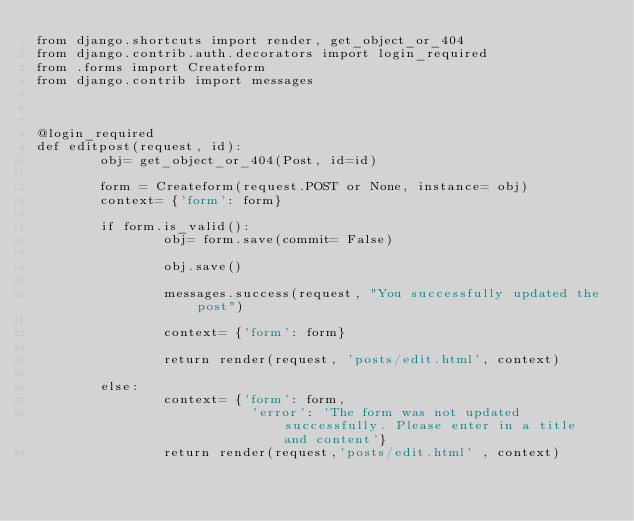Convert code to text. <code><loc_0><loc_0><loc_500><loc_500><_Python_>from django.shortcuts import render, get_object_or_404
from django.contrib.auth.decorators import login_required
from .forms import Createform
from django.contrib import messages



@login_required
def editpost(request, id):
        obj= get_object_or_404(Post, id=id)
        
        form = Createform(request.POST or None, instance= obj)
        context= {'form': form}

        if form.is_valid():
                obj= form.save(commit= False)

                obj.save()

                messages.success(request, "You successfully updated the post")

                context= {'form': form}

                return render(request, 'posts/edit.html', context)

        else:
                context= {'form': form,
                           'error': 'The form was not updated successfully. Please enter in a title and content'}
                return render(request,'posts/edit.html' , context)


</code> 